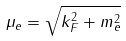<formula> <loc_0><loc_0><loc_500><loc_500>\mu _ { e } = \sqrt { k _ { F } ^ { 2 } + m _ { e } ^ { 2 } }</formula> 